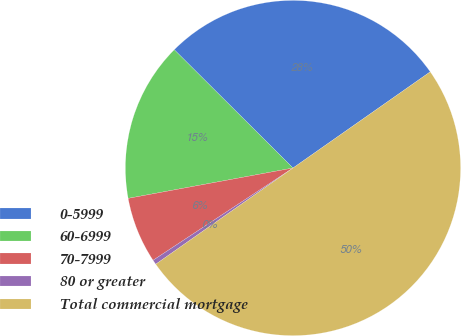<chart> <loc_0><loc_0><loc_500><loc_500><pie_chart><fcel>0-5999<fcel>60-6999<fcel>70-7999<fcel>80 or greater<fcel>Total commercial mortgage<nl><fcel>27.8%<fcel>15.37%<fcel>6.38%<fcel>0.45%<fcel>50.0%<nl></chart> 